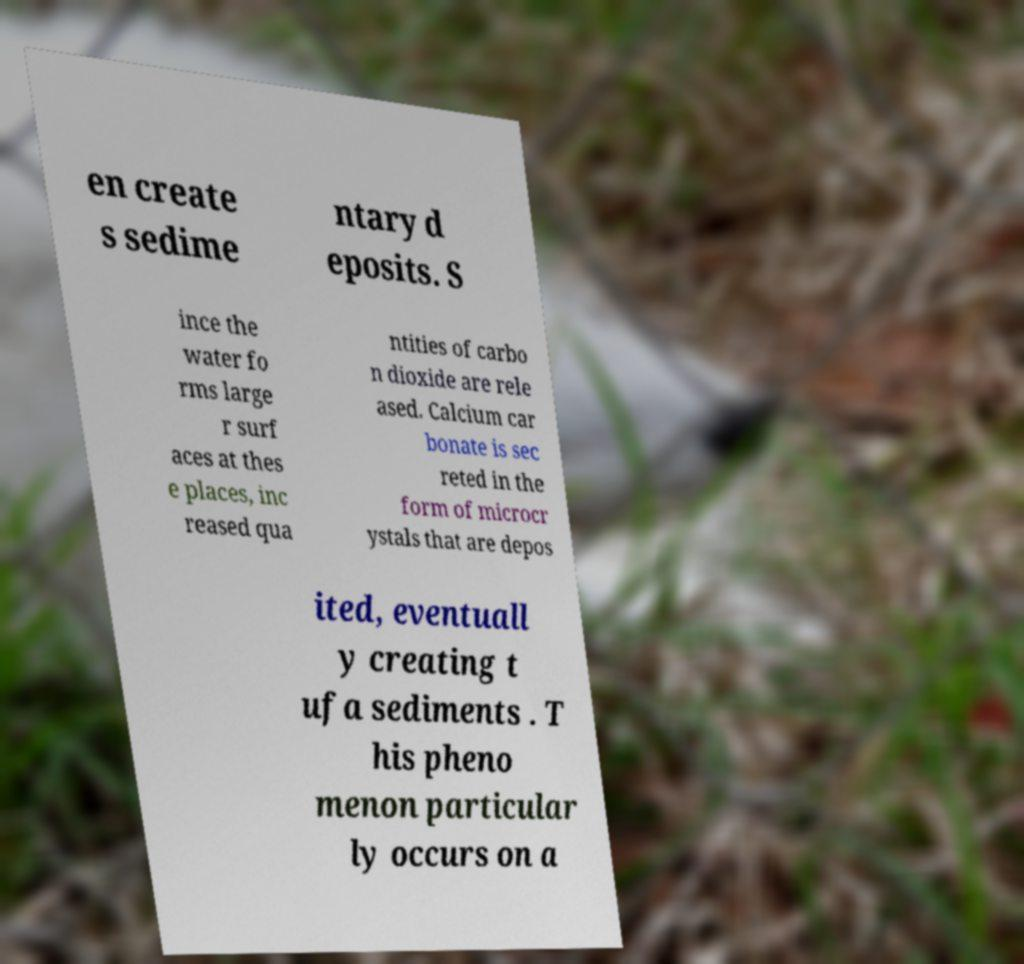I need the written content from this picture converted into text. Can you do that? en create s sedime ntary d eposits. S ince the water fo rms large r surf aces at thes e places, inc reased qua ntities of carbo n dioxide are rele ased. Calcium car bonate is sec reted in the form of microcr ystals that are depos ited, eventuall y creating t ufa sediments . T his pheno menon particular ly occurs on a 